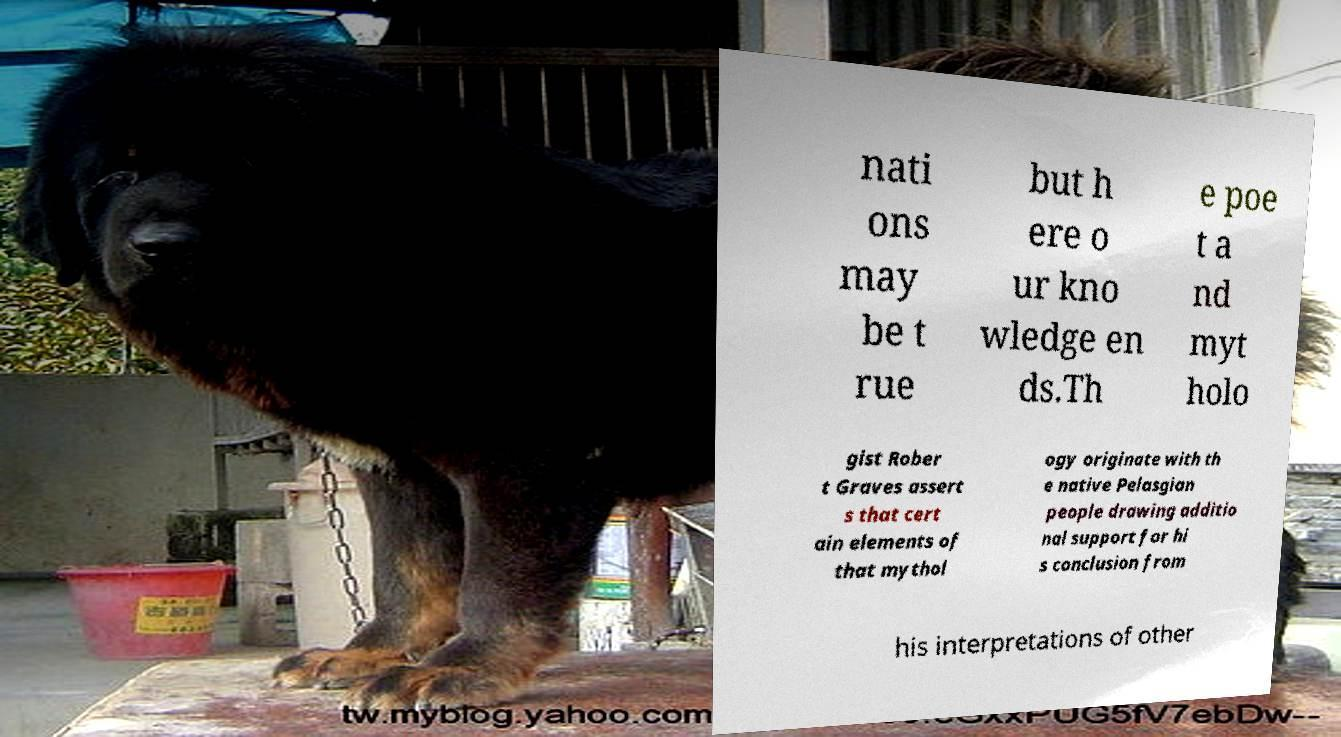I need the written content from this picture converted into text. Can you do that? nati ons may be t rue but h ere o ur kno wledge en ds.Th e poe t a nd myt holo gist Rober t Graves assert s that cert ain elements of that mythol ogy originate with th e native Pelasgian people drawing additio nal support for hi s conclusion from his interpretations of other 